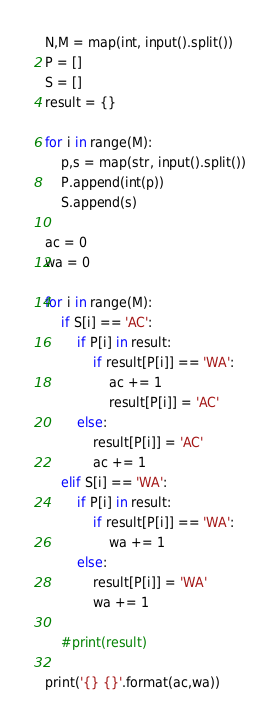Convert code to text. <code><loc_0><loc_0><loc_500><loc_500><_Python_>N,M = map(int, input().split())
P = []
S = []
result = {}

for i in range(M):
    p,s = map(str, input().split())
    P.append(int(p))
    S.append(s)

ac = 0
wa = 0

for i in range(M):
    if S[i] == 'AC':
        if P[i] in result:
            if result[P[i]] == 'WA':
                ac += 1
                result[P[i]] = 'AC'
        else:
            result[P[i]] = 'AC'
            ac += 1
    elif S[i] == 'WA':
        if P[i] in result:
            if result[P[i]] == 'WA':
                wa += 1
        else:
            result[P[i]] = 'WA'
            wa += 1
    
    #print(result)

print('{} {}'.format(ac,wa))</code> 